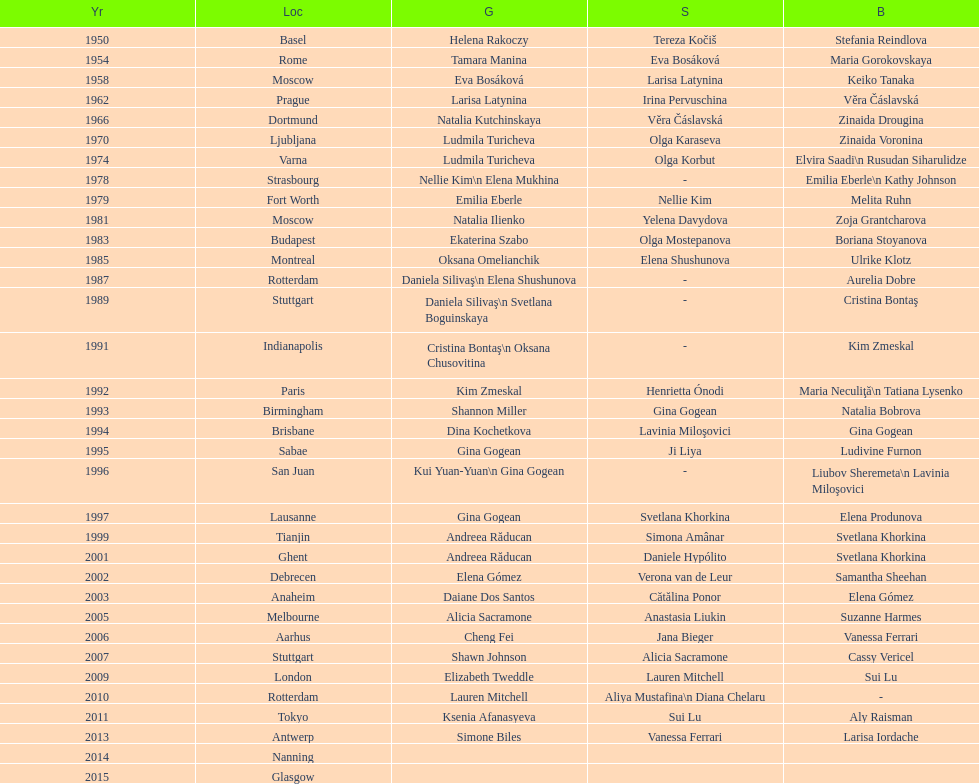Which two american rivals won consecutive floor exercise gold medals at the artistic gymnastics world championships in 1992 and 1993? Kim Zmeskal, Shannon Miller. 